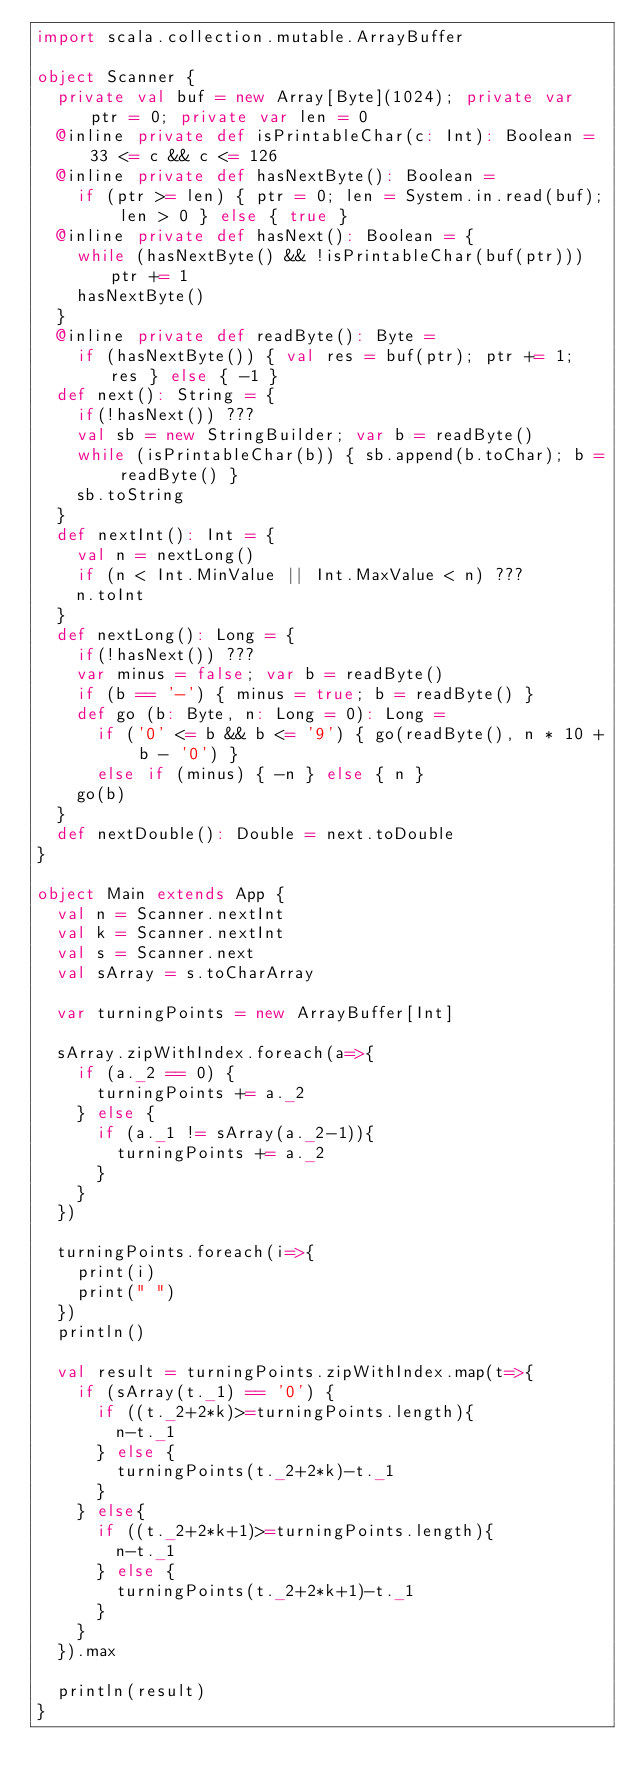Convert code to text. <code><loc_0><loc_0><loc_500><loc_500><_Scala_>import scala.collection.mutable.ArrayBuffer

object Scanner {
  private val buf = new Array[Byte](1024); private var ptr = 0; private var len = 0
  @inline private def isPrintableChar(c: Int): Boolean = 33 <= c && c <= 126
  @inline private def hasNextByte(): Boolean =
    if (ptr >= len) { ptr = 0; len = System.in.read(buf); len > 0 } else { true }
  @inline private def hasNext(): Boolean = {
    while (hasNextByte() && !isPrintableChar(buf(ptr))) ptr += 1
    hasNextByte()
  }
  @inline private def readByte(): Byte =
    if (hasNextByte()) { val res = buf(ptr); ptr += 1; res } else { -1 }
  def next(): String = {
    if(!hasNext()) ???
    val sb = new StringBuilder; var b = readByte()
    while (isPrintableChar(b)) { sb.append(b.toChar); b = readByte() }
    sb.toString
  }
  def nextInt(): Int = {
    val n = nextLong()
    if (n < Int.MinValue || Int.MaxValue < n) ???
    n.toInt
  }
  def nextLong(): Long = {
    if(!hasNext()) ???
    var minus = false; var b = readByte()
    if (b == '-') { minus = true; b = readByte() }
    def go (b: Byte, n: Long = 0): Long =
      if ('0' <= b && b <= '9') { go(readByte(), n * 10 + b - '0') }
      else if (minus) { -n } else { n }
    go(b)
  }
  def nextDouble(): Double = next.toDouble
}

object Main extends App {
  val n = Scanner.nextInt
  val k = Scanner.nextInt
  val s = Scanner.next
  val sArray = s.toCharArray

  var turningPoints = new ArrayBuffer[Int]

  sArray.zipWithIndex.foreach(a=>{
    if (a._2 == 0) {
      turningPoints += a._2
    } else {
      if (a._1 != sArray(a._2-1)){
        turningPoints += a._2
      }
    }
  })

  turningPoints.foreach(i=>{
    print(i)
    print(" ")
  })
  println()

  val result = turningPoints.zipWithIndex.map(t=>{
    if (sArray(t._1) == '0') {
      if ((t._2+2*k)>=turningPoints.length){
        n-t._1
      } else {
        turningPoints(t._2+2*k)-t._1
      }
    } else{
      if ((t._2+2*k+1)>=turningPoints.length){
        n-t._1
      } else {
        turningPoints(t._2+2*k+1)-t._1
      }
    }
  }).max

  println(result)
}</code> 